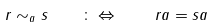<formula> <loc_0><loc_0><loc_500><loc_500>r \sim _ { a } s \quad \colon \Leftrightarrow \quad r a = s a</formula> 